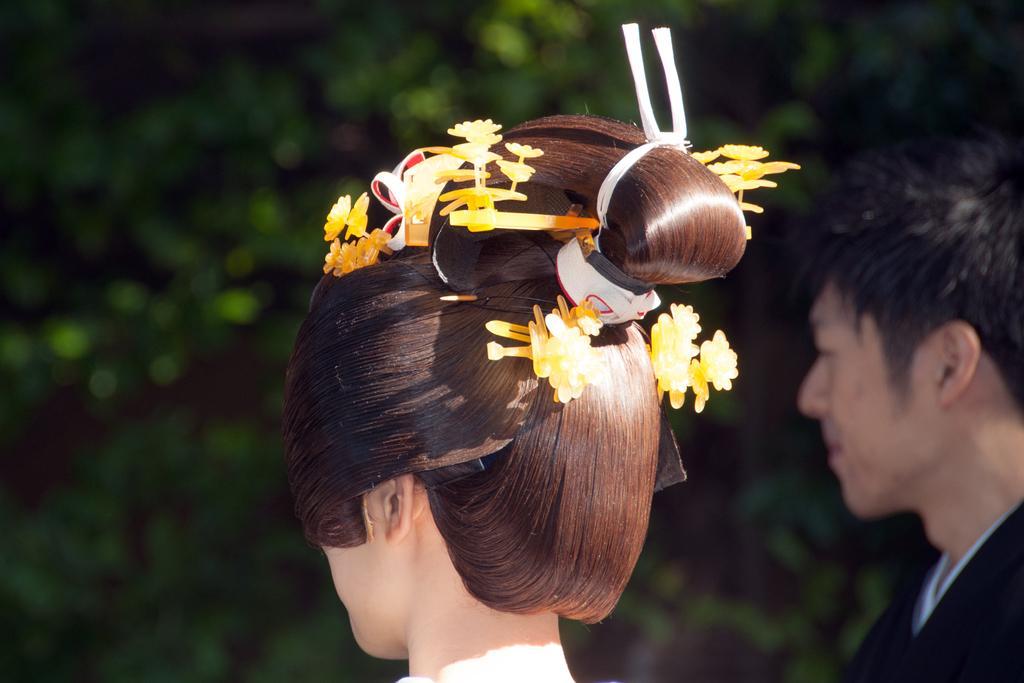Please provide a concise description of this image. In this image we can see a man and a woman. In the background, we can see greenery. 